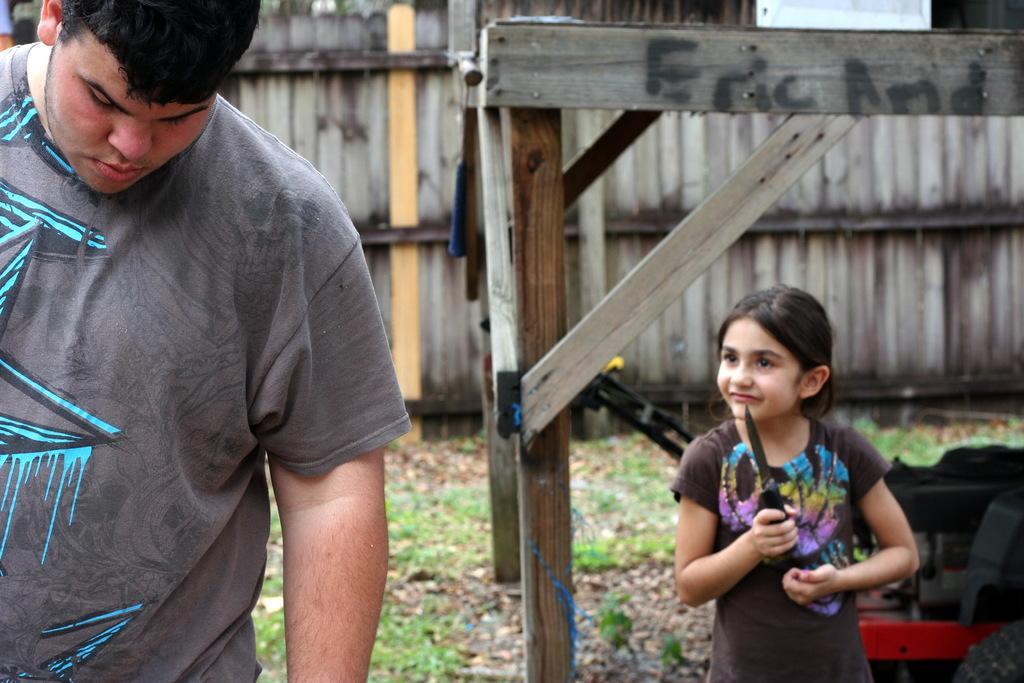Can you describe this image briefly? This is the picture of a kid who is holding the knife and to the side there is an other person and behind there is a wooden fencing on the floor. 